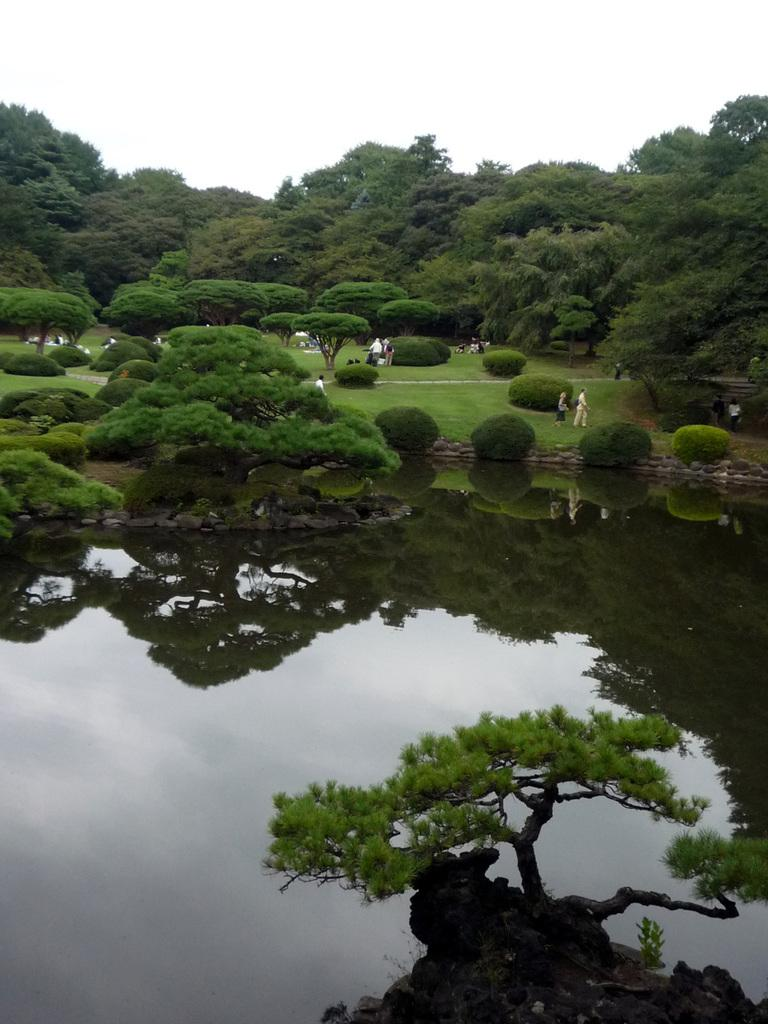What is the main subject in the center of the image? There is water in the center of the image. What type of vegetation can be seen at the top side of the image? There is greenery at the top side of the image. Are there any people visible in the image? Yes, there are people on the grassland. What type of beef is being served on the wire in the image? There is no beef or wire present in the image. 